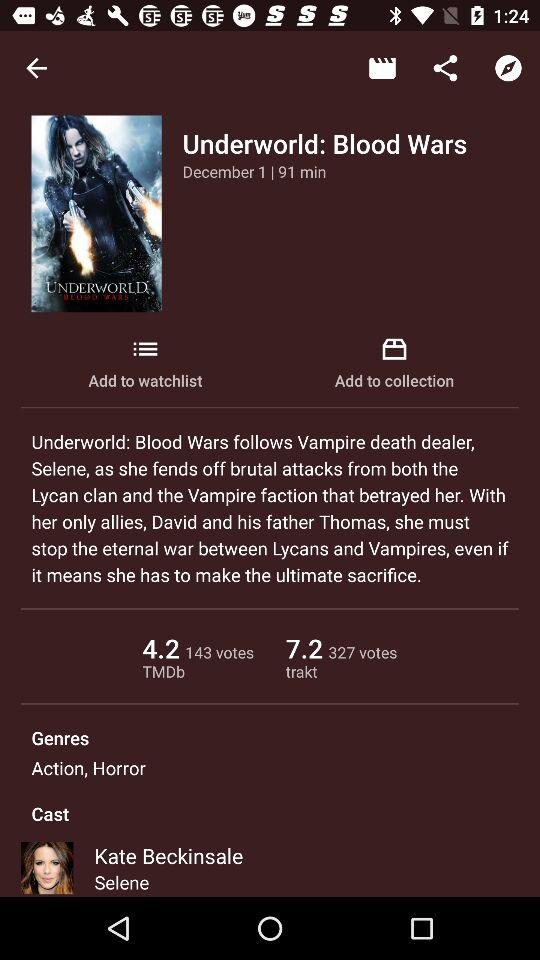What's the duration of the movie? The duration of the movie is 91 minutes. 